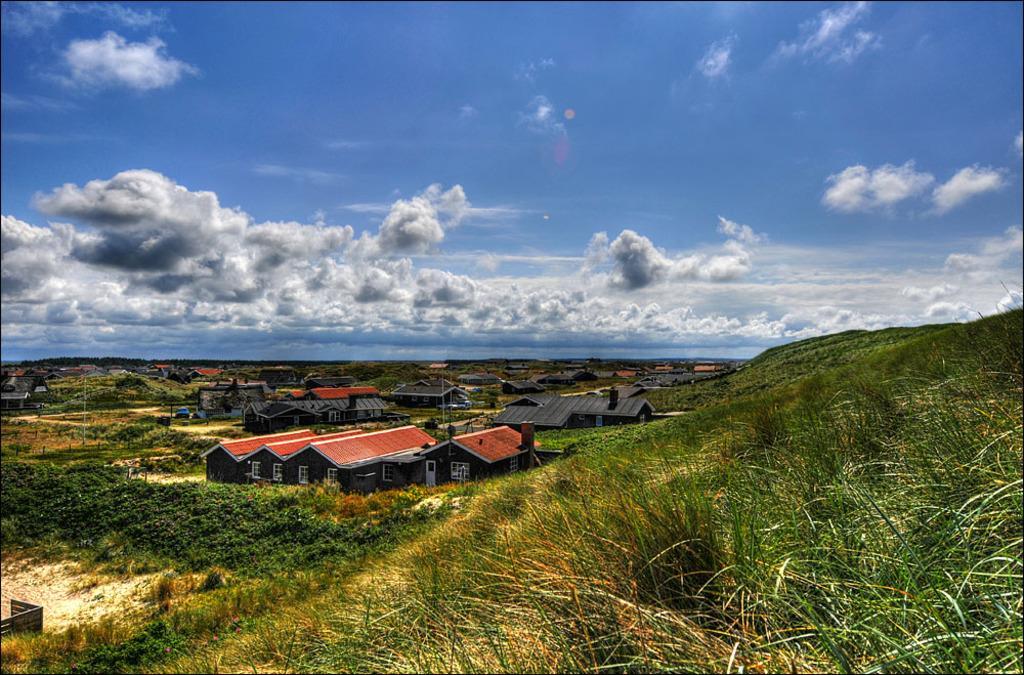In one or two sentences, can you explain what this image depicts? In this image, I can see the houses, trees, plants and grass. In the background, there is the sky. 